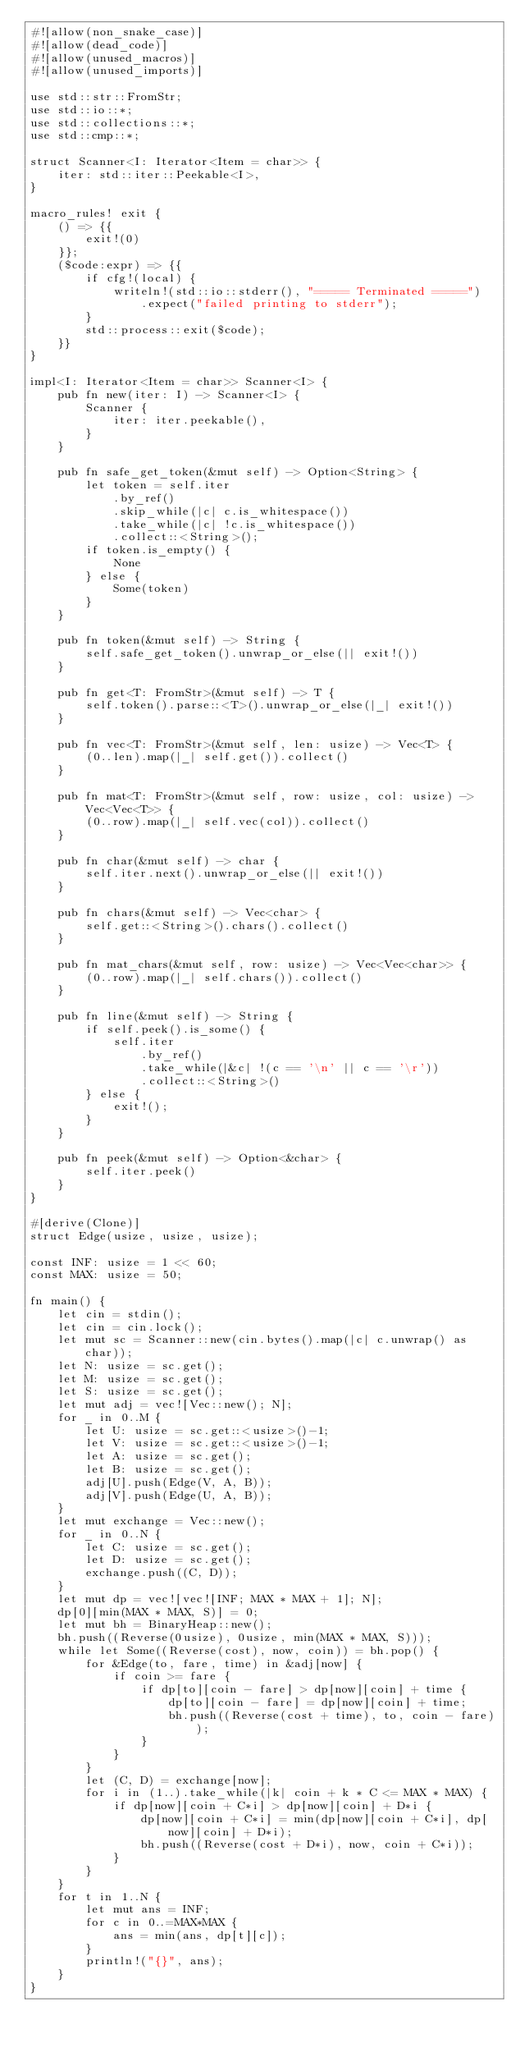<code> <loc_0><loc_0><loc_500><loc_500><_Rust_>#![allow(non_snake_case)]
#![allow(dead_code)]
#![allow(unused_macros)]
#![allow(unused_imports)]

use std::str::FromStr;
use std::io::*;
use std::collections::*;
use std::cmp::*;

struct Scanner<I: Iterator<Item = char>> {
    iter: std::iter::Peekable<I>,
}

macro_rules! exit {
    () => {{
        exit!(0)
    }};
    ($code:expr) => {{
        if cfg!(local) {
            writeln!(std::io::stderr(), "===== Terminated =====")
                .expect("failed printing to stderr");
        }
        std::process::exit($code);
    }}
}

impl<I: Iterator<Item = char>> Scanner<I> {
    pub fn new(iter: I) -> Scanner<I> {
        Scanner {
            iter: iter.peekable(),
        }
    }

    pub fn safe_get_token(&mut self) -> Option<String> {
        let token = self.iter
            .by_ref()
            .skip_while(|c| c.is_whitespace())
            .take_while(|c| !c.is_whitespace())
            .collect::<String>();
        if token.is_empty() {
            None
        } else {
            Some(token)
        }
    }

    pub fn token(&mut self) -> String {
        self.safe_get_token().unwrap_or_else(|| exit!())
    }

    pub fn get<T: FromStr>(&mut self) -> T {
        self.token().parse::<T>().unwrap_or_else(|_| exit!())
    }

    pub fn vec<T: FromStr>(&mut self, len: usize) -> Vec<T> {
        (0..len).map(|_| self.get()).collect()
    }

    pub fn mat<T: FromStr>(&mut self, row: usize, col: usize) -> Vec<Vec<T>> {
        (0..row).map(|_| self.vec(col)).collect()
    }

    pub fn char(&mut self) -> char {
        self.iter.next().unwrap_or_else(|| exit!())
    }

    pub fn chars(&mut self) -> Vec<char> {
        self.get::<String>().chars().collect()
    }

    pub fn mat_chars(&mut self, row: usize) -> Vec<Vec<char>> {
        (0..row).map(|_| self.chars()).collect()
    }

    pub fn line(&mut self) -> String {
        if self.peek().is_some() {
            self.iter
                .by_ref()
                .take_while(|&c| !(c == '\n' || c == '\r'))
                .collect::<String>()
        } else {
            exit!();
        }
    }

    pub fn peek(&mut self) -> Option<&char> {
        self.iter.peek()
    }
}

#[derive(Clone)]
struct Edge(usize, usize, usize);

const INF: usize = 1 << 60;
const MAX: usize = 50;

fn main() {
    let cin = stdin();
    let cin = cin.lock();
    let mut sc = Scanner::new(cin.bytes().map(|c| c.unwrap() as char));
    let N: usize = sc.get();
    let M: usize = sc.get();
    let S: usize = sc.get();
    let mut adj = vec![Vec::new(); N];
    for _ in 0..M {
        let U: usize = sc.get::<usize>()-1;
        let V: usize = sc.get::<usize>()-1;
        let A: usize = sc.get();
        let B: usize = sc.get();
        adj[U].push(Edge(V, A, B));
        adj[V].push(Edge(U, A, B));
    }
    let mut exchange = Vec::new();
    for _ in 0..N {
        let C: usize = sc.get();
        let D: usize = sc.get();
        exchange.push((C, D));
    }
    let mut dp = vec![vec![INF; MAX * MAX + 1]; N];
    dp[0][min(MAX * MAX, S)] = 0;
    let mut bh = BinaryHeap::new();
    bh.push((Reverse(0usize), 0usize, min(MAX * MAX, S)));
    while let Some((Reverse(cost), now, coin)) = bh.pop() {
        for &Edge(to, fare, time) in &adj[now] {
            if coin >= fare {
                if dp[to][coin - fare] > dp[now][coin] + time {
                    dp[to][coin - fare] = dp[now][coin] + time;
                    bh.push((Reverse(cost + time), to, coin - fare));
                }
            }
        }
        let (C, D) = exchange[now];
        for i in (1..).take_while(|k| coin + k * C <= MAX * MAX) {
            if dp[now][coin + C*i] > dp[now][coin] + D*i {
                dp[now][coin + C*i] = min(dp[now][coin + C*i], dp[now][coin] + D*i);
                bh.push((Reverse(cost + D*i), now, coin + C*i));
            }
        }
    }
    for t in 1..N {
        let mut ans = INF;
        for c in 0..=MAX*MAX {
            ans = min(ans, dp[t][c]);
        }
        println!("{}", ans);
    }
}
</code> 